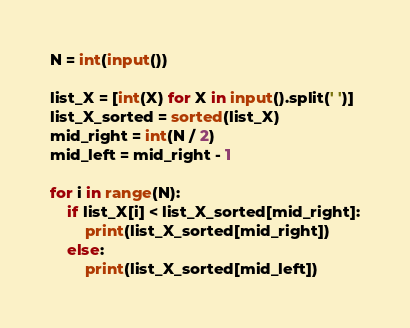<code> <loc_0><loc_0><loc_500><loc_500><_Python_>N = int(input())

list_X = [int(X) for X in input().split(' ')]
list_X_sorted = sorted(list_X)
mid_right = int(N / 2)
mid_left = mid_right - 1

for i in range(N):
    if list_X[i] < list_X_sorted[mid_right]:
        print(list_X_sorted[mid_right])
    else:
        print(list_X_sorted[mid_left])</code> 